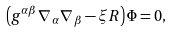Convert formula to latex. <formula><loc_0><loc_0><loc_500><loc_500>\left ( g ^ { \alpha \beta } \nabla _ { \, \alpha } \nabla _ { \, \beta } - \xi R \right ) \Phi = 0 ,</formula> 